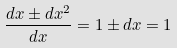<formula> <loc_0><loc_0><loc_500><loc_500>\frac { d x \pm d x ^ { 2 } } { d x } = 1 \pm d x = 1</formula> 